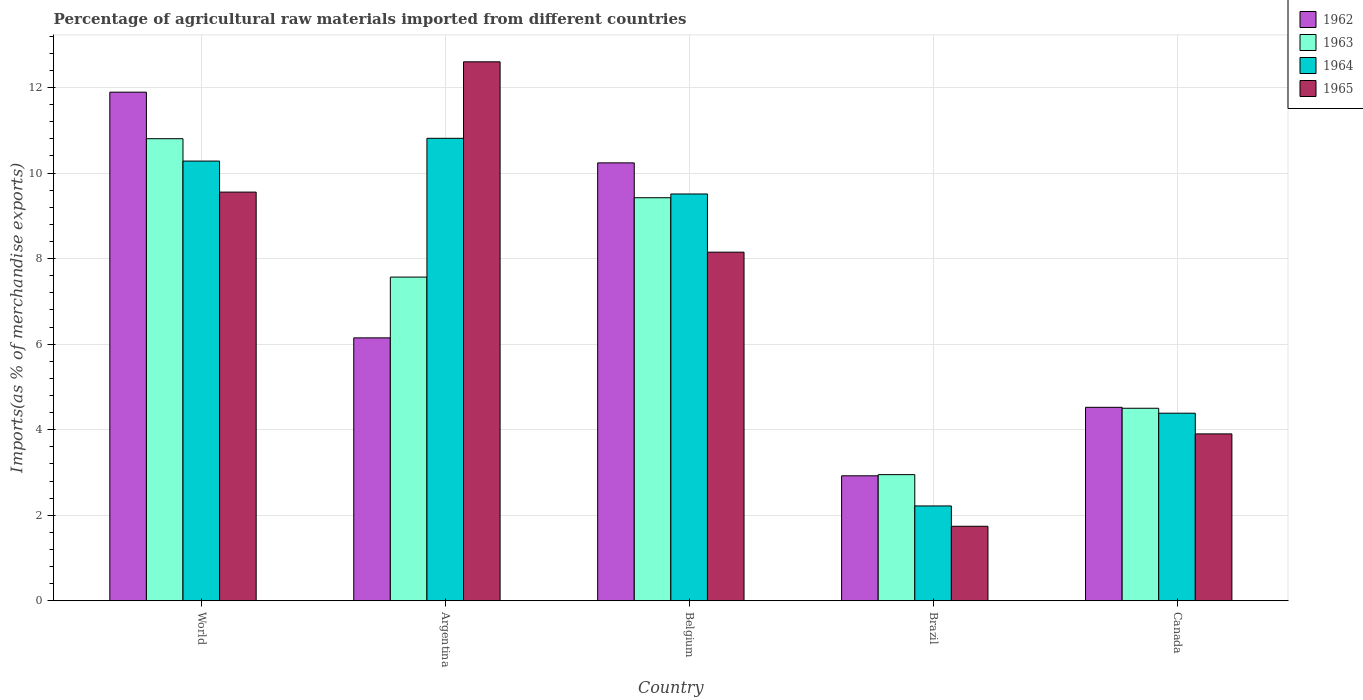How many different coloured bars are there?
Ensure brevity in your answer.  4. How many groups of bars are there?
Provide a succinct answer. 5. Are the number of bars on each tick of the X-axis equal?
Make the answer very short. Yes. How many bars are there on the 4th tick from the right?
Provide a succinct answer. 4. What is the percentage of imports to different countries in 1963 in Argentina?
Ensure brevity in your answer.  7.57. Across all countries, what is the maximum percentage of imports to different countries in 1965?
Give a very brief answer. 12.6. Across all countries, what is the minimum percentage of imports to different countries in 1963?
Provide a short and direct response. 2.95. In which country was the percentage of imports to different countries in 1962 minimum?
Your answer should be compact. Brazil. What is the total percentage of imports to different countries in 1965 in the graph?
Make the answer very short. 35.95. What is the difference between the percentage of imports to different countries in 1965 in Belgium and that in World?
Provide a succinct answer. -1.4. What is the difference between the percentage of imports to different countries in 1964 in World and the percentage of imports to different countries in 1963 in Argentina?
Provide a succinct answer. 2.71. What is the average percentage of imports to different countries in 1965 per country?
Make the answer very short. 7.19. What is the difference between the percentage of imports to different countries of/in 1962 and percentage of imports to different countries of/in 1963 in Canada?
Offer a very short reply. 0.02. In how many countries, is the percentage of imports to different countries in 1965 greater than 6 %?
Keep it short and to the point. 3. What is the ratio of the percentage of imports to different countries in 1963 in Canada to that in World?
Your response must be concise. 0.42. What is the difference between the highest and the second highest percentage of imports to different countries in 1963?
Your answer should be very brief. -1.38. What is the difference between the highest and the lowest percentage of imports to different countries in 1964?
Your answer should be very brief. 8.6. In how many countries, is the percentage of imports to different countries in 1965 greater than the average percentage of imports to different countries in 1965 taken over all countries?
Provide a succinct answer. 3. What does the 2nd bar from the right in Argentina represents?
Give a very brief answer. 1964. Is it the case that in every country, the sum of the percentage of imports to different countries in 1965 and percentage of imports to different countries in 1963 is greater than the percentage of imports to different countries in 1962?
Provide a short and direct response. Yes. Are the values on the major ticks of Y-axis written in scientific E-notation?
Make the answer very short. No. Does the graph contain any zero values?
Make the answer very short. No. Where does the legend appear in the graph?
Your response must be concise. Top right. What is the title of the graph?
Your answer should be compact. Percentage of agricultural raw materials imported from different countries. What is the label or title of the Y-axis?
Provide a short and direct response. Imports(as % of merchandise exports). What is the Imports(as % of merchandise exports) in 1962 in World?
Give a very brief answer. 11.89. What is the Imports(as % of merchandise exports) of 1963 in World?
Provide a succinct answer. 10.8. What is the Imports(as % of merchandise exports) in 1964 in World?
Ensure brevity in your answer.  10.28. What is the Imports(as % of merchandise exports) in 1965 in World?
Offer a terse response. 9.56. What is the Imports(as % of merchandise exports) in 1962 in Argentina?
Provide a succinct answer. 6.15. What is the Imports(as % of merchandise exports) in 1963 in Argentina?
Give a very brief answer. 7.57. What is the Imports(as % of merchandise exports) in 1964 in Argentina?
Your answer should be very brief. 10.81. What is the Imports(as % of merchandise exports) in 1965 in Argentina?
Make the answer very short. 12.6. What is the Imports(as % of merchandise exports) in 1962 in Belgium?
Provide a short and direct response. 10.24. What is the Imports(as % of merchandise exports) of 1963 in Belgium?
Give a very brief answer. 9.42. What is the Imports(as % of merchandise exports) of 1964 in Belgium?
Provide a succinct answer. 9.51. What is the Imports(as % of merchandise exports) of 1965 in Belgium?
Your response must be concise. 8.15. What is the Imports(as % of merchandise exports) in 1962 in Brazil?
Your answer should be very brief. 2.92. What is the Imports(as % of merchandise exports) in 1963 in Brazil?
Provide a short and direct response. 2.95. What is the Imports(as % of merchandise exports) of 1964 in Brazil?
Provide a succinct answer. 2.22. What is the Imports(as % of merchandise exports) of 1965 in Brazil?
Keep it short and to the point. 1.74. What is the Imports(as % of merchandise exports) of 1962 in Canada?
Keep it short and to the point. 4.52. What is the Imports(as % of merchandise exports) in 1963 in Canada?
Make the answer very short. 4.5. What is the Imports(as % of merchandise exports) in 1964 in Canada?
Your answer should be compact. 4.39. What is the Imports(as % of merchandise exports) of 1965 in Canada?
Offer a very short reply. 3.9. Across all countries, what is the maximum Imports(as % of merchandise exports) in 1962?
Make the answer very short. 11.89. Across all countries, what is the maximum Imports(as % of merchandise exports) of 1963?
Make the answer very short. 10.8. Across all countries, what is the maximum Imports(as % of merchandise exports) in 1964?
Offer a very short reply. 10.81. Across all countries, what is the maximum Imports(as % of merchandise exports) in 1965?
Provide a short and direct response. 12.6. Across all countries, what is the minimum Imports(as % of merchandise exports) in 1962?
Provide a short and direct response. 2.92. Across all countries, what is the minimum Imports(as % of merchandise exports) in 1963?
Give a very brief answer. 2.95. Across all countries, what is the minimum Imports(as % of merchandise exports) in 1964?
Your response must be concise. 2.22. Across all countries, what is the minimum Imports(as % of merchandise exports) in 1965?
Provide a succinct answer. 1.74. What is the total Imports(as % of merchandise exports) in 1962 in the graph?
Ensure brevity in your answer.  35.72. What is the total Imports(as % of merchandise exports) of 1963 in the graph?
Provide a short and direct response. 35.25. What is the total Imports(as % of merchandise exports) in 1964 in the graph?
Your answer should be compact. 37.21. What is the total Imports(as % of merchandise exports) of 1965 in the graph?
Your response must be concise. 35.95. What is the difference between the Imports(as % of merchandise exports) of 1962 in World and that in Argentina?
Provide a short and direct response. 5.74. What is the difference between the Imports(as % of merchandise exports) in 1963 in World and that in Argentina?
Make the answer very short. 3.24. What is the difference between the Imports(as % of merchandise exports) of 1964 in World and that in Argentina?
Give a very brief answer. -0.53. What is the difference between the Imports(as % of merchandise exports) in 1965 in World and that in Argentina?
Keep it short and to the point. -3.05. What is the difference between the Imports(as % of merchandise exports) of 1962 in World and that in Belgium?
Make the answer very short. 1.65. What is the difference between the Imports(as % of merchandise exports) in 1963 in World and that in Belgium?
Ensure brevity in your answer.  1.38. What is the difference between the Imports(as % of merchandise exports) in 1964 in World and that in Belgium?
Provide a short and direct response. 0.77. What is the difference between the Imports(as % of merchandise exports) in 1965 in World and that in Belgium?
Provide a succinct answer. 1.4. What is the difference between the Imports(as % of merchandise exports) of 1962 in World and that in Brazil?
Provide a succinct answer. 8.97. What is the difference between the Imports(as % of merchandise exports) of 1963 in World and that in Brazil?
Offer a terse response. 7.85. What is the difference between the Imports(as % of merchandise exports) of 1964 in World and that in Brazil?
Your answer should be very brief. 8.06. What is the difference between the Imports(as % of merchandise exports) in 1965 in World and that in Brazil?
Your answer should be compact. 7.81. What is the difference between the Imports(as % of merchandise exports) in 1962 in World and that in Canada?
Your response must be concise. 7.37. What is the difference between the Imports(as % of merchandise exports) of 1963 in World and that in Canada?
Your response must be concise. 6.3. What is the difference between the Imports(as % of merchandise exports) in 1964 in World and that in Canada?
Ensure brevity in your answer.  5.89. What is the difference between the Imports(as % of merchandise exports) of 1965 in World and that in Canada?
Provide a short and direct response. 5.65. What is the difference between the Imports(as % of merchandise exports) in 1962 in Argentina and that in Belgium?
Ensure brevity in your answer.  -4.09. What is the difference between the Imports(as % of merchandise exports) in 1963 in Argentina and that in Belgium?
Give a very brief answer. -1.86. What is the difference between the Imports(as % of merchandise exports) of 1964 in Argentina and that in Belgium?
Keep it short and to the point. 1.3. What is the difference between the Imports(as % of merchandise exports) in 1965 in Argentina and that in Belgium?
Give a very brief answer. 4.45. What is the difference between the Imports(as % of merchandise exports) in 1962 in Argentina and that in Brazil?
Give a very brief answer. 3.22. What is the difference between the Imports(as % of merchandise exports) in 1963 in Argentina and that in Brazil?
Your response must be concise. 4.62. What is the difference between the Imports(as % of merchandise exports) in 1964 in Argentina and that in Brazil?
Give a very brief answer. 8.6. What is the difference between the Imports(as % of merchandise exports) of 1965 in Argentina and that in Brazil?
Make the answer very short. 10.86. What is the difference between the Imports(as % of merchandise exports) in 1962 in Argentina and that in Canada?
Offer a terse response. 1.62. What is the difference between the Imports(as % of merchandise exports) of 1963 in Argentina and that in Canada?
Give a very brief answer. 3.07. What is the difference between the Imports(as % of merchandise exports) of 1964 in Argentina and that in Canada?
Offer a very short reply. 6.43. What is the difference between the Imports(as % of merchandise exports) in 1965 in Argentina and that in Canada?
Offer a very short reply. 8.7. What is the difference between the Imports(as % of merchandise exports) in 1962 in Belgium and that in Brazil?
Your answer should be compact. 7.32. What is the difference between the Imports(as % of merchandise exports) in 1963 in Belgium and that in Brazil?
Your answer should be compact. 6.47. What is the difference between the Imports(as % of merchandise exports) in 1964 in Belgium and that in Brazil?
Your answer should be very brief. 7.29. What is the difference between the Imports(as % of merchandise exports) in 1965 in Belgium and that in Brazil?
Provide a succinct answer. 6.41. What is the difference between the Imports(as % of merchandise exports) in 1962 in Belgium and that in Canada?
Ensure brevity in your answer.  5.72. What is the difference between the Imports(as % of merchandise exports) of 1963 in Belgium and that in Canada?
Provide a short and direct response. 4.92. What is the difference between the Imports(as % of merchandise exports) in 1964 in Belgium and that in Canada?
Make the answer very short. 5.13. What is the difference between the Imports(as % of merchandise exports) of 1965 in Belgium and that in Canada?
Your answer should be very brief. 4.25. What is the difference between the Imports(as % of merchandise exports) of 1962 in Brazil and that in Canada?
Give a very brief answer. -1.6. What is the difference between the Imports(as % of merchandise exports) in 1963 in Brazil and that in Canada?
Give a very brief answer. -1.55. What is the difference between the Imports(as % of merchandise exports) in 1964 in Brazil and that in Canada?
Keep it short and to the point. -2.17. What is the difference between the Imports(as % of merchandise exports) in 1965 in Brazil and that in Canada?
Make the answer very short. -2.16. What is the difference between the Imports(as % of merchandise exports) in 1962 in World and the Imports(as % of merchandise exports) in 1963 in Argentina?
Offer a terse response. 4.32. What is the difference between the Imports(as % of merchandise exports) in 1962 in World and the Imports(as % of merchandise exports) in 1964 in Argentina?
Give a very brief answer. 1.08. What is the difference between the Imports(as % of merchandise exports) of 1962 in World and the Imports(as % of merchandise exports) of 1965 in Argentina?
Your response must be concise. -0.71. What is the difference between the Imports(as % of merchandise exports) in 1963 in World and the Imports(as % of merchandise exports) in 1964 in Argentina?
Provide a short and direct response. -0.01. What is the difference between the Imports(as % of merchandise exports) of 1963 in World and the Imports(as % of merchandise exports) of 1965 in Argentina?
Offer a very short reply. -1.8. What is the difference between the Imports(as % of merchandise exports) of 1964 in World and the Imports(as % of merchandise exports) of 1965 in Argentina?
Your answer should be very brief. -2.32. What is the difference between the Imports(as % of merchandise exports) in 1962 in World and the Imports(as % of merchandise exports) in 1963 in Belgium?
Your response must be concise. 2.47. What is the difference between the Imports(as % of merchandise exports) in 1962 in World and the Imports(as % of merchandise exports) in 1964 in Belgium?
Keep it short and to the point. 2.38. What is the difference between the Imports(as % of merchandise exports) of 1962 in World and the Imports(as % of merchandise exports) of 1965 in Belgium?
Provide a short and direct response. 3.74. What is the difference between the Imports(as % of merchandise exports) of 1963 in World and the Imports(as % of merchandise exports) of 1964 in Belgium?
Your response must be concise. 1.29. What is the difference between the Imports(as % of merchandise exports) in 1963 in World and the Imports(as % of merchandise exports) in 1965 in Belgium?
Give a very brief answer. 2.65. What is the difference between the Imports(as % of merchandise exports) of 1964 in World and the Imports(as % of merchandise exports) of 1965 in Belgium?
Give a very brief answer. 2.13. What is the difference between the Imports(as % of merchandise exports) of 1962 in World and the Imports(as % of merchandise exports) of 1963 in Brazil?
Your answer should be very brief. 8.94. What is the difference between the Imports(as % of merchandise exports) in 1962 in World and the Imports(as % of merchandise exports) in 1964 in Brazil?
Your answer should be compact. 9.67. What is the difference between the Imports(as % of merchandise exports) in 1962 in World and the Imports(as % of merchandise exports) in 1965 in Brazil?
Provide a short and direct response. 10.15. What is the difference between the Imports(as % of merchandise exports) of 1963 in World and the Imports(as % of merchandise exports) of 1964 in Brazil?
Give a very brief answer. 8.59. What is the difference between the Imports(as % of merchandise exports) of 1963 in World and the Imports(as % of merchandise exports) of 1965 in Brazil?
Keep it short and to the point. 9.06. What is the difference between the Imports(as % of merchandise exports) of 1964 in World and the Imports(as % of merchandise exports) of 1965 in Brazil?
Give a very brief answer. 8.54. What is the difference between the Imports(as % of merchandise exports) in 1962 in World and the Imports(as % of merchandise exports) in 1963 in Canada?
Offer a very short reply. 7.39. What is the difference between the Imports(as % of merchandise exports) in 1962 in World and the Imports(as % of merchandise exports) in 1964 in Canada?
Keep it short and to the point. 7.51. What is the difference between the Imports(as % of merchandise exports) of 1962 in World and the Imports(as % of merchandise exports) of 1965 in Canada?
Offer a very short reply. 7.99. What is the difference between the Imports(as % of merchandise exports) of 1963 in World and the Imports(as % of merchandise exports) of 1964 in Canada?
Provide a succinct answer. 6.42. What is the difference between the Imports(as % of merchandise exports) in 1963 in World and the Imports(as % of merchandise exports) in 1965 in Canada?
Give a very brief answer. 6.9. What is the difference between the Imports(as % of merchandise exports) of 1964 in World and the Imports(as % of merchandise exports) of 1965 in Canada?
Provide a succinct answer. 6.38. What is the difference between the Imports(as % of merchandise exports) in 1962 in Argentina and the Imports(as % of merchandise exports) in 1963 in Belgium?
Offer a terse response. -3.28. What is the difference between the Imports(as % of merchandise exports) in 1962 in Argentina and the Imports(as % of merchandise exports) in 1964 in Belgium?
Your answer should be compact. -3.36. What is the difference between the Imports(as % of merchandise exports) in 1962 in Argentina and the Imports(as % of merchandise exports) in 1965 in Belgium?
Provide a short and direct response. -2. What is the difference between the Imports(as % of merchandise exports) in 1963 in Argentina and the Imports(as % of merchandise exports) in 1964 in Belgium?
Give a very brief answer. -1.94. What is the difference between the Imports(as % of merchandise exports) of 1963 in Argentina and the Imports(as % of merchandise exports) of 1965 in Belgium?
Ensure brevity in your answer.  -0.58. What is the difference between the Imports(as % of merchandise exports) of 1964 in Argentina and the Imports(as % of merchandise exports) of 1965 in Belgium?
Provide a short and direct response. 2.66. What is the difference between the Imports(as % of merchandise exports) of 1962 in Argentina and the Imports(as % of merchandise exports) of 1963 in Brazil?
Give a very brief answer. 3.2. What is the difference between the Imports(as % of merchandise exports) of 1962 in Argentina and the Imports(as % of merchandise exports) of 1964 in Brazil?
Offer a terse response. 3.93. What is the difference between the Imports(as % of merchandise exports) of 1962 in Argentina and the Imports(as % of merchandise exports) of 1965 in Brazil?
Give a very brief answer. 4.41. What is the difference between the Imports(as % of merchandise exports) of 1963 in Argentina and the Imports(as % of merchandise exports) of 1964 in Brazil?
Your answer should be compact. 5.35. What is the difference between the Imports(as % of merchandise exports) in 1963 in Argentina and the Imports(as % of merchandise exports) in 1965 in Brazil?
Offer a very short reply. 5.83. What is the difference between the Imports(as % of merchandise exports) in 1964 in Argentina and the Imports(as % of merchandise exports) in 1965 in Brazil?
Offer a terse response. 9.07. What is the difference between the Imports(as % of merchandise exports) of 1962 in Argentina and the Imports(as % of merchandise exports) of 1963 in Canada?
Your answer should be compact. 1.65. What is the difference between the Imports(as % of merchandise exports) of 1962 in Argentina and the Imports(as % of merchandise exports) of 1964 in Canada?
Provide a short and direct response. 1.76. What is the difference between the Imports(as % of merchandise exports) in 1962 in Argentina and the Imports(as % of merchandise exports) in 1965 in Canada?
Keep it short and to the point. 2.25. What is the difference between the Imports(as % of merchandise exports) in 1963 in Argentina and the Imports(as % of merchandise exports) in 1964 in Canada?
Provide a succinct answer. 3.18. What is the difference between the Imports(as % of merchandise exports) in 1963 in Argentina and the Imports(as % of merchandise exports) in 1965 in Canada?
Keep it short and to the point. 3.67. What is the difference between the Imports(as % of merchandise exports) in 1964 in Argentina and the Imports(as % of merchandise exports) in 1965 in Canada?
Provide a succinct answer. 6.91. What is the difference between the Imports(as % of merchandise exports) of 1962 in Belgium and the Imports(as % of merchandise exports) of 1963 in Brazil?
Your answer should be very brief. 7.29. What is the difference between the Imports(as % of merchandise exports) in 1962 in Belgium and the Imports(as % of merchandise exports) in 1964 in Brazil?
Your response must be concise. 8.02. What is the difference between the Imports(as % of merchandise exports) in 1962 in Belgium and the Imports(as % of merchandise exports) in 1965 in Brazil?
Provide a short and direct response. 8.5. What is the difference between the Imports(as % of merchandise exports) of 1963 in Belgium and the Imports(as % of merchandise exports) of 1964 in Brazil?
Ensure brevity in your answer.  7.21. What is the difference between the Imports(as % of merchandise exports) of 1963 in Belgium and the Imports(as % of merchandise exports) of 1965 in Brazil?
Your response must be concise. 7.68. What is the difference between the Imports(as % of merchandise exports) of 1964 in Belgium and the Imports(as % of merchandise exports) of 1965 in Brazil?
Keep it short and to the point. 7.77. What is the difference between the Imports(as % of merchandise exports) of 1962 in Belgium and the Imports(as % of merchandise exports) of 1963 in Canada?
Make the answer very short. 5.74. What is the difference between the Imports(as % of merchandise exports) in 1962 in Belgium and the Imports(as % of merchandise exports) in 1964 in Canada?
Your answer should be very brief. 5.85. What is the difference between the Imports(as % of merchandise exports) in 1962 in Belgium and the Imports(as % of merchandise exports) in 1965 in Canada?
Provide a short and direct response. 6.34. What is the difference between the Imports(as % of merchandise exports) in 1963 in Belgium and the Imports(as % of merchandise exports) in 1964 in Canada?
Your answer should be very brief. 5.04. What is the difference between the Imports(as % of merchandise exports) of 1963 in Belgium and the Imports(as % of merchandise exports) of 1965 in Canada?
Make the answer very short. 5.52. What is the difference between the Imports(as % of merchandise exports) of 1964 in Belgium and the Imports(as % of merchandise exports) of 1965 in Canada?
Offer a very short reply. 5.61. What is the difference between the Imports(as % of merchandise exports) of 1962 in Brazil and the Imports(as % of merchandise exports) of 1963 in Canada?
Make the answer very short. -1.58. What is the difference between the Imports(as % of merchandise exports) of 1962 in Brazil and the Imports(as % of merchandise exports) of 1964 in Canada?
Provide a succinct answer. -1.46. What is the difference between the Imports(as % of merchandise exports) of 1962 in Brazil and the Imports(as % of merchandise exports) of 1965 in Canada?
Offer a very short reply. -0.98. What is the difference between the Imports(as % of merchandise exports) of 1963 in Brazil and the Imports(as % of merchandise exports) of 1964 in Canada?
Give a very brief answer. -1.44. What is the difference between the Imports(as % of merchandise exports) in 1963 in Brazil and the Imports(as % of merchandise exports) in 1965 in Canada?
Offer a very short reply. -0.95. What is the difference between the Imports(as % of merchandise exports) of 1964 in Brazil and the Imports(as % of merchandise exports) of 1965 in Canada?
Offer a very short reply. -1.68. What is the average Imports(as % of merchandise exports) in 1962 per country?
Your answer should be compact. 7.14. What is the average Imports(as % of merchandise exports) in 1963 per country?
Offer a terse response. 7.05. What is the average Imports(as % of merchandise exports) in 1964 per country?
Keep it short and to the point. 7.44. What is the average Imports(as % of merchandise exports) in 1965 per country?
Offer a terse response. 7.19. What is the difference between the Imports(as % of merchandise exports) in 1962 and Imports(as % of merchandise exports) in 1963 in World?
Give a very brief answer. 1.09. What is the difference between the Imports(as % of merchandise exports) in 1962 and Imports(as % of merchandise exports) in 1964 in World?
Provide a short and direct response. 1.61. What is the difference between the Imports(as % of merchandise exports) in 1962 and Imports(as % of merchandise exports) in 1965 in World?
Your answer should be very brief. 2.34. What is the difference between the Imports(as % of merchandise exports) of 1963 and Imports(as % of merchandise exports) of 1964 in World?
Your response must be concise. 0.52. What is the difference between the Imports(as % of merchandise exports) in 1963 and Imports(as % of merchandise exports) in 1965 in World?
Provide a succinct answer. 1.25. What is the difference between the Imports(as % of merchandise exports) in 1964 and Imports(as % of merchandise exports) in 1965 in World?
Make the answer very short. 0.73. What is the difference between the Imports(as % of merchandise exports) in 1962 and Imports(as % of merchandise exports) in 1963 in Argentina?
Offer a terse response. -1.42. What is the difference between the Imports(as % of merchandise exports) in 1962 and Imports(as % of merchandise exports) in 1964 in Argentina?
Offer a terse response. -4.67. What is the difference between the Imports(as % of merchandise exports) in 1962 and Imports(as % of merchandise exports) in 1965 in Argentina?
Ensure brevity in your answer.  -6.45. What is the difference between the Imports(as % of merchandise exports) of 1963 and Imports(as % of merchandise exports) of 1964 in Argentina?
Your answer should be very brief. -3.24. What is the difference between the Imports(as % of merchandise exports) of 1963 and Imports(as % of merchandise exports) of 1965 in Argentina?
Your answer should be very brief. -5.03. What is the difference between the Imports(as % of merchandise exports) in 1964 and Imports(as % of merchandise exports) in 1965 in Argentina?
Your response must be concise. -1.79. What is the difference between the Imports(as % of merchandise exports) in 1962 and Imports(as % of merchandise exports) in 1963 in Belgium?
Make the answer very short. 0.82. What is the difference between the Imports(as % of merchandise exports) in 1962 and Imports(as % of merchandise exports) in 1964 in Belgium?
Provide a succinct answer. 0.73. What is the difference between the Imports(as % of merchandise exports) in 1962 and Imports(as % of merchandise exports) in 1965 in Belgium?
Provide a short and direct response. 2.09. What is the difference between the Imports(as % of merchandise exports) in 1963 and Imports(as % of merchandise exports) in 1964 in Belgium?
Offer a terse response. -0.09. What is the difference between the Imports(as % of merchandise exports) in 1963 and Imports(as % of merchandise exports) in 1965 in Belgium?
Provide a succinct answer. 1.27. What is the difference between the Imports(as % of merchandise exports) of 1964 and Imports(as % of merchandise exports) of 1965 in Belgium?
Ensure brevity in your answer.  1.36. What is the difference between the Imports(as % of merchandise exports) in 1962 and Imports(as % of merchandise exports) in 1963 in Brazil?
Keep it short and to the point. -0.03. What is the difference between the Imports(as % of merchandise exports) of 1962 and Imports(as % of merchandise exports) of 1964 in Brazil?
Your answer should be compact. 0.7. What is the difference between the Imports(as % of merchandise exports) in 1962 and Imports(as % of merchandise exports) in 1965 in Brazil?
Offer a terse response. 1.18. What is the difference between the Imports(as % of merchandise exports) of 1963 and Imports(as % of merchandise exports) of 1964 in Brazil?
Give a very brief answer. 0.73. What is the difference between the Imports(as % of merchandise exports) of 1963 and Imports(as % of merchandise exports) of 1965 in Brazil?
Your response must be concise. 1.21. What is the difference between the Imports(as % of merchandise exports) in 1964 and Imports(as % of merchandise exports) in 1965 in Brazil?
Provide a succinct answer. 0.48. What is the difference between the Imports(as % of merchandise exports) in 1962 and Imports(as % of merchandise exports) in 1963 in Canada?
Offer a very short reply. 0.02. What is the difference between the Imports(as % of merchandise exports) in 1962 and Imports(as % of merchandise exports) in 1964 in Canada?
Offer a very short reply. 0.14. What is the difference between the Imports(as % of merchandise exports) of 1962 and Imports(as % of merchandise exports) of 1965 in Canada?
Your answer should be compact. 0.62. What is the difference between the Imports(as % of merchandise exports) in 1963 and Imports(as % of merchandise exports) in 1964 in Canada?
Give a very brief answer. 0.12. What is the difference between the Imports(as % of merchandise exports) of 1963 and Imports(as % of merchandise exports) of 1965 in Canada?
Offer a very short reply. 0.6. What is the difference between the Imports(as % of merchandise exports) in 1964 and Imports(as % of merchandise exports) in 1965 in Canada?
Ensure brevity in your answer.  0.48. What is the ratio of the Imports(as % of merchandise exports) of 1962 in World to that in Argentina?
Your answer should be very brief. 1.93. What is the ratio of the Imports(as % of merchandise exports) of 1963 in World to that in Argentina?
Your response must be concise. 1.43. What is the ratio of the Imports(as % of merchandise exports) in 1964 in World to that in Argentina?
Make the answer very short. 0.95. What is the ratio of the Imports(as % of merchandise exports) of 1965 in World to that in Argentina?
Ensure brevity in your answer.  0.76. What is the ratio of the Imports(as % of merchandise exports) of 1962 in World to that in Belgium?
Ensure brevity in your answer.  1.16. What is the ratio of the Imports(as % of merchandise exports) of 1963 in World to that in Belgium?
Your answer should be compact. 1.15. What is the ratio of the Imports(as % of merchandise exports) of 1964 in World to that in Belgium?
Provide a succinct answer. 1.08. What is the ratio of the Imports(as % of merchandise exports) in 1965 in World to that in Belgium?
Make the answer very short. 1.17. What is the ratio of the Imports(as % of merchandise exports) of 1962 in World to that in Brazil?
Your response must be concise. 4.07. What is the ratio of the Imports(as % of merchandise exports) in 1963 in World to that in Brazil?
Give a very brief answer. 3.66. What is the ratio of the Imports(as % of merchandise exports) of 1964 in World to that in Brazil?
Provide a succinct answer. 4.64. What is the ratio of the Imports(as % of merchandise exports) of 1965 in World to that in Brazil?
Offer a terse response. 5.49. What is the ratio of the Imports(as % of merchandise exports) in 1962 in World to that in Canada?
Your answer should be compact. 2.63. What is the ratio of the Imports(as % of merchandise exports) in 1963 in World to that in Canada?
Your response must be concise. 2.4. What is the ratio of the Imports(as % of merchandise exports) of 1964 in World to that in Canada?
Offer a terse response. 2.34. What is the ratio of the Imports(as % of merchandise exports) of 1965 in World to that in Canada?
Your answer should be compact. 2.45. What is the ratio of the Imports(as % of merchandise exports) in 1962 in Argentina to that in Belgium?
Keep it short and to the point. 0.6. What is the ratio of the Imports(as % of merchandise exports) of 1963 in Argentina to that in Belgium?
Your response must be concise. 0.8. What is the ratio of the Imports(as % of merchandise exports) of 1964 in Argentina to that in Belgium?
Your answer should be compact. 1.14. What is the ratio of the Imports(as % of merchandise exports) in 1965 in Argentina to that in Belgium?
Ensure brevity in your answer.  1.55. What is the ratio of the Imports(as % of merchandise exports) in 1962 in Argentina to that in Brazil?
Your answer should be compact. 2.1. What is the ratio of the Imports(as % of merchandise exports) in 1963 in Argentina to that in Brazil?
Keep it short and to the point. 2.57. What is the ratio of the Imports(as % of merchandise exports) in 1964 in Argentina to that in Brazil?
Keep it short and to the point. 4.88. What is the ratio of the Imports(as % of merchandise exports) in 1965 in Argentina to that in Brazil?
Offer a very short reply. 7.23. What is the ratio of the Imports(as % of merchandise exports) of 1962 in Argentina to that in Canada?
Your answer should be very brief. 1.36. What is the ratio of the Imports(as % of merchandise exports) in 1963 in Argentina to that in Canada?
Provide a short and direct response. 1.68. What is the ratio of the Imports(as % of merchandise exports) of 1964 in Argentina to that in Canada?
Your answer should be very brief. 2.47. What is the ratio of the Imports(as % of merchandise exports) in 1965 in Argentina to that in Canada?
Your answer should be very brief. 3.23. What is the ratio of the Imports(as % of merchandise exports) of 1962 in Belgium to that in Brazil?
Your response must be concise. 3.5. What is the ratio of the Imports(as % of merchandise exports) of 1963 in Belgium to that in Brazil?
Make the answer very short. 3.2. What is the ratio of the Imports(as % of merchandise exports) in 1964 in Belgium to that in Brazil?
Provide a succinct answer. 4.29. What is the ratio of the Imports(as % of merchandise exports) in 1965 in Belgium to that in Brazil?
Make the answer very short. 4.68. What is the ratio of the Imports(as % of merchandise exports) in 1962 in Belgium to that in Canada?
Give a very brief answer. 2.26. What is the ratio of the Imports(as % of merchandise exports) of 1963 in Belgium to that in Canada?
Your response must be concise. 2.09. What is the ratio of the Imports(as % of merchandise exports) in 1964 in Belgium to that in Canada?
Your response must be concise. 2.17. What is the ratio of the Imports(as % of merchandise exports) of 1965 in Belgium to that in Canada?
Give a very brief answer. 2.09. What is the ratio of the Imports(as % of merchandise exports) of 1962 in Brazil to that in Canada?
Your answer should be compact. 0.65. What is the ratio of the Imports(as % of merchandise exports) in 1963 in Brazil to that in Canada?
Make the answer very short. 0.66. What is the ratio of the Imports(as % of merchandise exports) of 1964 in Brazil to that in Canada?
Provide a short and direct response. 0.51. What is the ratio of the Imports(as % of merchandise exports) of 1965 in Brazil to that in Canada?
Give a very brief answer. 0.45. What is the difference between the highest and the second highest Imports(as % of merchandise exports) of 1962?
Provide a succinct answer. 1.65. What is the difference between the highest and the second highest Imports(as % of merchandise exports) in 1963?
Your answer should be compact. 1.38. What is the difference between the highest and the second highest Imports(as % of merchandise exports) in 1964?
Give a very brief answer. 0.53. What is the difference between the highest and the second highest Imports(as % of merchandise exports) of 1965?
Keep it short and to the point. 3.05. What is the difference between the highest and the lowest Imports(as % of merchandise exports) in 1962?
Your answer should be very brief. 8.97. What is the difference between the highest and the lowest Imports(as % of merchandise exports) of 1963?
Offer a terse response. 7.85. What is the difference between the highest and the lowest Imports(as % of merchandise exports) in 1964?
Offer a very short reply. 8.6. What is the difference between the highest and the lowest Imports(as % of merchandise exports) of 1965?
Give a very brief answer. 10.86. 